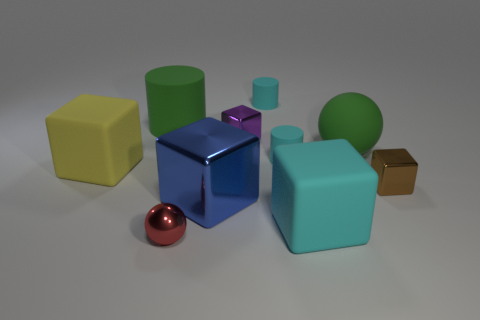How many objects in total are displayed in the image? The image shows a total of 10 objects, consisting of an assortment of cubes, cylinders, spheres, and a single cone. 